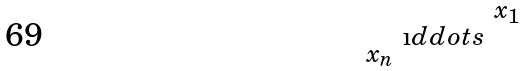<formula> <loc_0><loc_0><loc_500><loc_500>\begin{smallmatrix} & & x _ { 1 } \\ & \i d d o t s & \\ x _ { n } & & \end{smallmatrix}</formula> 